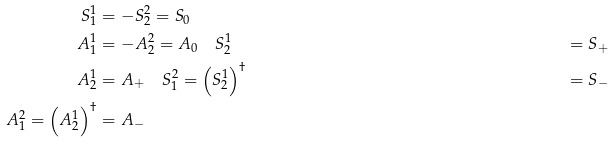<formula> <loc_0><loc_0><loc_500><loc_500>S ^ { 1 } _ { 1 } & = - S ^ { 2 } _ { 2 } = S _ { 0 } \\ A ^ { 1 } _ { 1 } & = - A ^ { 2 } _ { 2 } = A _ { 0 } \quad S ^ { 1 } _ { 2 } & = S _ { + } \\ A ^ { 1 } _ { 2 } & = A _ { + } \quad S ^ { 2 } _ { 1 } = \left ( { S ^ { 1 } _ { 2 } } \right ) ^ { \dag } & = S _ { - } \\ A ^ { 2 } _ { 1 } = \left ( { A ^ { 1 } _ { 2 } } \right ) ^ { \dag } & = A _ { - }</formula> 